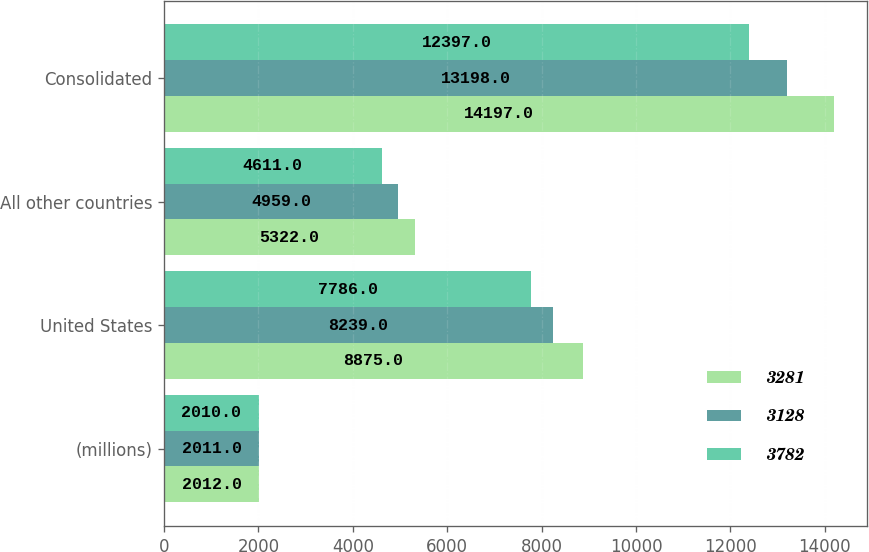Convert chart. <chart><loc_0><loc_0><loc_500><loc_500><stacked_bar_chart><ecel><fcel>(millions)<fcel>United States<fcel>All other countries<fcel>Consolidated<nl><fcel>3281<fcel>2012<fcel>8875<fcel>5322<fcel>14197<nl><fcel>3128<fcel>2011<fcel>8239<fcel>4959<fcel>13198<nl><fcel>3782<fcel>2010<fcel>7786<fcel>4611<fcel>12397<nl></chart> 